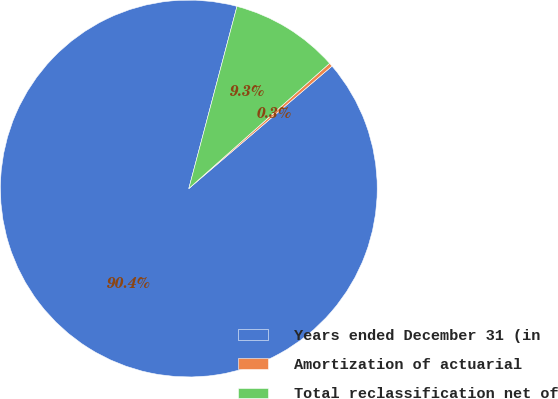Convert chart. <chart><loc_0><loc_0><loc_500><loc_500><pie_chart><fcel>Years ended December 31 (in<fcel>Amortization of actuarial<fcel>Total reclassification net of<nl><fcel>90.37%<fcel>0.31%<fcel>9.32%<nl></chart> 